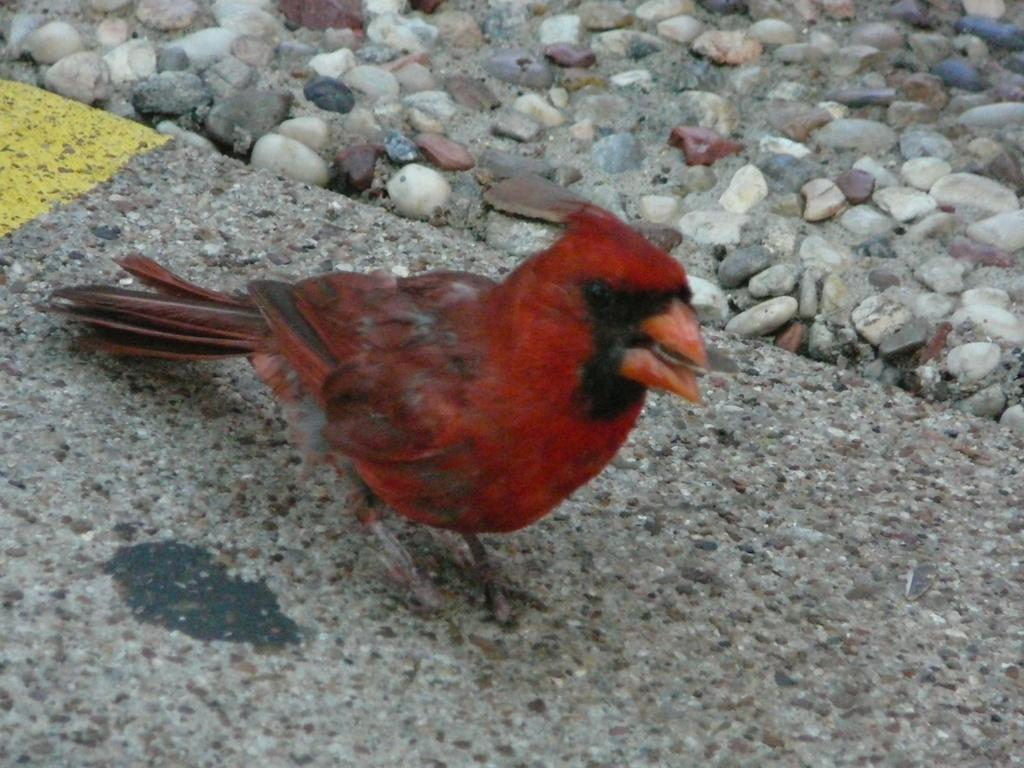What type of bird can be seen in the image? There is a red color bird in the image. Where is the bird located? The bird is on the road. What can be seen in the background of the image? There are stones visible in the background of the image. What type of carriage is the bird using to travel on the road? There is no carriage present in the image; the bird is simply on the road. Can you tell me what the bird is talking about with the stones in the background? The bird is not talking with the stones in the background, as birds do not have the ability to talk. 